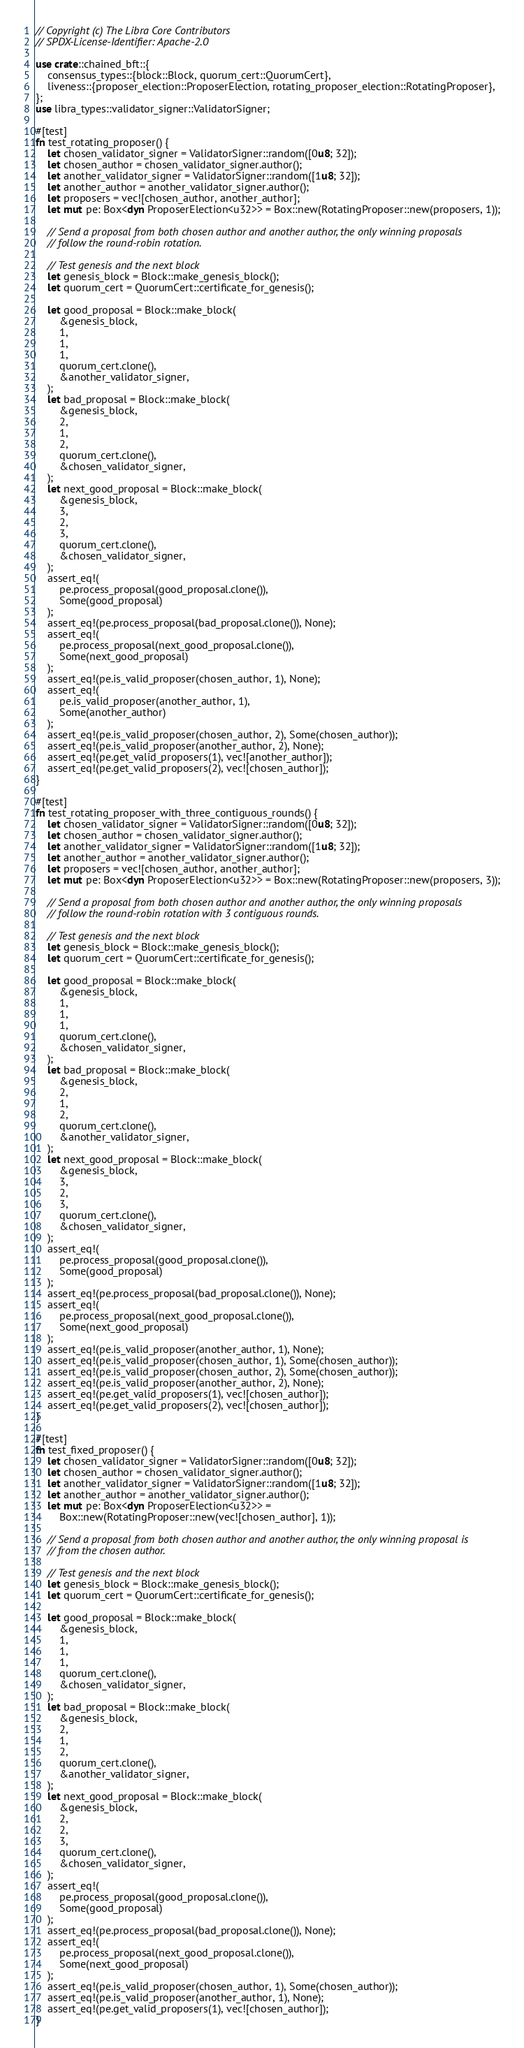<code> <loc_0><loc_0><loc_500><loc_500><_Rust_>// Copyright (c) The Libra Core Contributors
// SPDX-License-Identifier: Apache-2.0

use crate::chained_bft::{
    consensus_types::{block::Block, quorum_cert::QuorumCert},
    liveness::{proposer_election::ProposerElection, rotating_proposer_election::RotatingProposer},
};
use libra_types::validator_signer::ValidatorSigner;

#[test]
fn test_rotating_proposer() {
    let chosen_validator_signer = ValidatorSigner::random([0u8; 32]);
    let chosen_author = chosen_validator_signer.author();
    let another_validator_signer = ValidatorSigner::random([1u8; 32]);
    let another_author = another_validator_signer.author();
    let proposers = vec![chosen_author, another_author];
    let mut pe: Box<dyn ProposerElection<u32>> = Box::new(RotatingProposer::new(proposers, 1));

    // Send a proposal from both chosen author and another author, the only winning proposals
    // follow the round-robin rotation.

    // Test genesis and the next block
    let genesis_block = Block::make_genesis_block();
    let quorum_cert = QuorumCert::certificate_for_genesis();

    let good_proposal = Block::make_block(
        &genesis_block,
        1,
        1,
        1,
        quorum_cert.clone(),
        &another_validator_signer,
    );
    let bad_proposal = Block::make_block(
        &genesis_block,
        2,
        1,
        2,
        quorum_cert.clone(),
        &chosen_validator_signer,
    );
    let next_good_proposal = Block::make_block(
        &genesis_block,
        3,
        2,
        3,
        quorum_cert.clone(),
        &chosen_validator_signer,
    );
    assert_eq!(
        pe.process_proposal(good_proposal.clone()),
        Some(good_proposal)
    );
    assert_eq!(pe.process_proposal(bad_proposal.clone()), None);
    assert_eq!(
        pe.process_proposal(next_good_proposal.clone()),
        Some(next_good_proposal)
    );
    assert_eq!(pe.is_valid_proposer(chosen_author, 1), None);
    assert_eq!(
        pe.is_valid_proposer(another_author, 1),
        Some(another_author)
    );
    assert_eq!(pe.is_valid_proposer(chosen_author, 2), Some(chosen_author));
    assert_eq!(pe.is_valid_proposer(another_author, 2), None);
    assert_eq!(pe.get_valid_proposers(1), vec![another_author]);
    assert_eq!(pe.get_valid_proposers(2), vec![chosen_author]);
}

#[test]
fn test_rotating_proposer_with_three_contiguous_rounds() {
    let chosen_validator_signer = ValidatorSigner::random([0u8; 32]);
    let chosen_author = chosen_validator_signer.author();
    let another_validator_signer = ValidatorSigner::random([1u8; 32]);
    let another_author = another_validator_signer.author();
    let proposers = vec![chosen_author, another_author];
    let mut pe: Box<dyn ProposerElection<u32>> = Box::new(RotatingProposer::new(proposers, 3));

    // Send a proposal from both chosen author and another author, the only winning proposals
    // follow the round-robin rotation with 3 contiguous rounds.

    // Test genesis and the next block
    let genesis_block = Block::make_genesis_block();
    let quorum_cert = QuorumCert::certificate_for_genesis();

    let good_proposal = Block::make_block(
        &genesis_block,
        1,
        1,
        1,
        quorum_cert.clone(),
        &chosen_validator_signer,
    );
    let bad_proposal = Block::make_block(
        &genesis_block,
        2,
        1,
        2,
        quorum_cert.clone(),
        &another_validator_signer,
    );
    let next_good_proposal = Block::make_block(
        &genesis_block,
        3,
        2,
        3,
        quorum_cert.clone(),
        &chosen_validator_signer,
    );
    assert_eq!(
        pe.process_proposal(good_proposal.clone()),
        Some(good_proposal)
    );
    assert_eq!(pe.process_proposal(bad_proposal.clone()), None);
    assert_eq!(
        pe.process_proposal(next_good_proposal.clone()),
        Some(next_good_proposal)
    );
    assert_eq!(pe.is_valid_proposer(another_author, 1), None);
    assert_eq!(pe.is_valid_proposer(chosen_author, 1), Some(chosen_author));
    assert_eq!(pe.is_valid_proposer(chosen_author, 2), Some(chosen_author));
    assert_eq!(pe.is_valid_proposer(another_author, 2), None);
    assert_eq!(pe.get_valid_proposers(1), vec![chosen_author]);
    assert_eq!(pe.get_valid_proposers(2), vec![chosen_author]);
}

#[test]
fn test_fixed_proposer() {
    let chosen_validator_signer = ValidatorSigner::random([0u8; 32]);
    let chosen_author = chosen_validator_signer.author();
    let another_validator_signer = ValidatorSigner::random([1u8; 32]);
    let another_author = another_validator_signer.author();
    let mut pe: Box<dyn ProposerElection<u32>> =
        Box::new(RotatingProposer::new(vec![chosen_author], 1));

    // Send a proposal from both chosen author and another author, the only winning proposal is
    // from the chosen author.

    // Test genesis and the next block
    let genesis_block = Block::make_genesis_block();
    let quorum_cert = QuorumCert::certificate_for_genesis();

    let good_proposal = Block::make_block(
        &genesis_block,
        1,
        1,
        1,
        quorum_cert.clone(),
        &chosen_validator_signer,
    );
    let bad_proposal = Block::make_block(
        &genesis_block,
        2,
        1,
        2,
        quorum_cert.clone(),
        &another_validator_signer,
    );
    let next_good_proposal = Block::make_block(
        &genesis_block,
        2,
        2,
        3,
        quorum_cert.clone(),
        &chosen_validator_signer,
    );
    assert_eq!(
        pe.process_proposal(good_proposal.clone()),
        Some(good_proposal)
    );
    assert_eq!(pe.process_proposal(bad_proposal.clone()), None);
    assert_eq!(
        pe.process_proposal(next_good_proposal.clone()),
        Some(next_good_proposal)
    );
    assert_eq!(pe.is_valid_proposer(chosen_author, 1), Some(chosen_author));
    assert_eq!(pe.is_valid_proposer(another_author, 1), None);
    assert_eq!(pe.get_valid_proposers(1), vec![chosen_author]);
}
</code> 